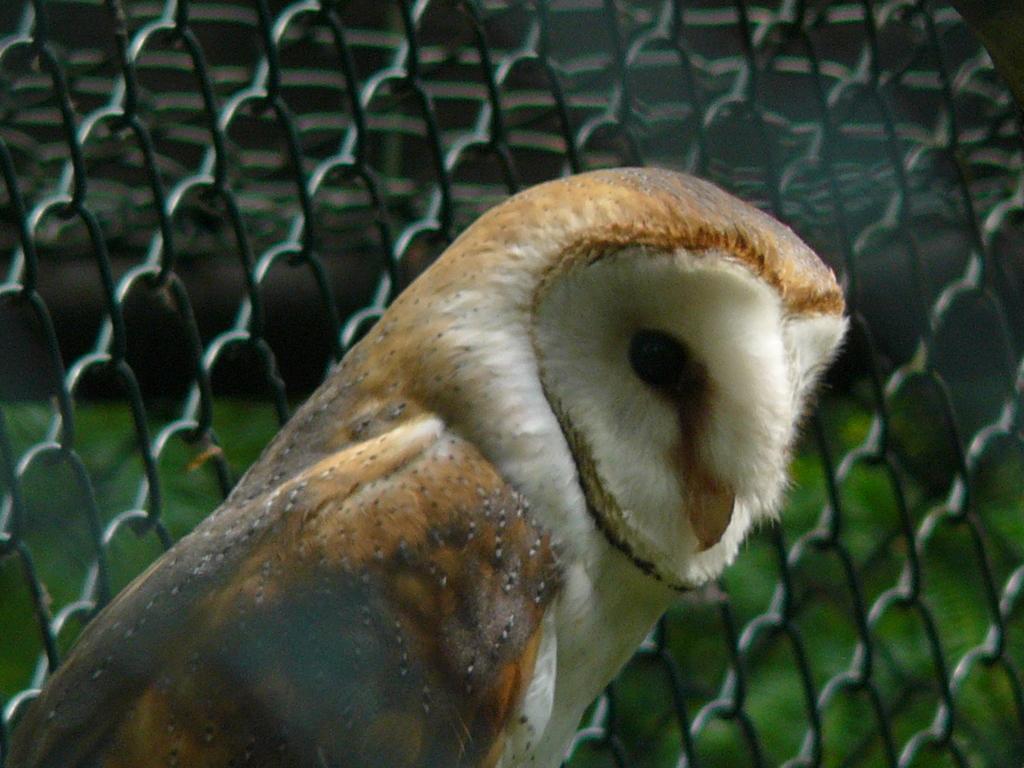How would you summarize this image in a sentence or two? In this image I can see a bird which is in brown,white and black color. Back I can see a net fencing and green grass. 